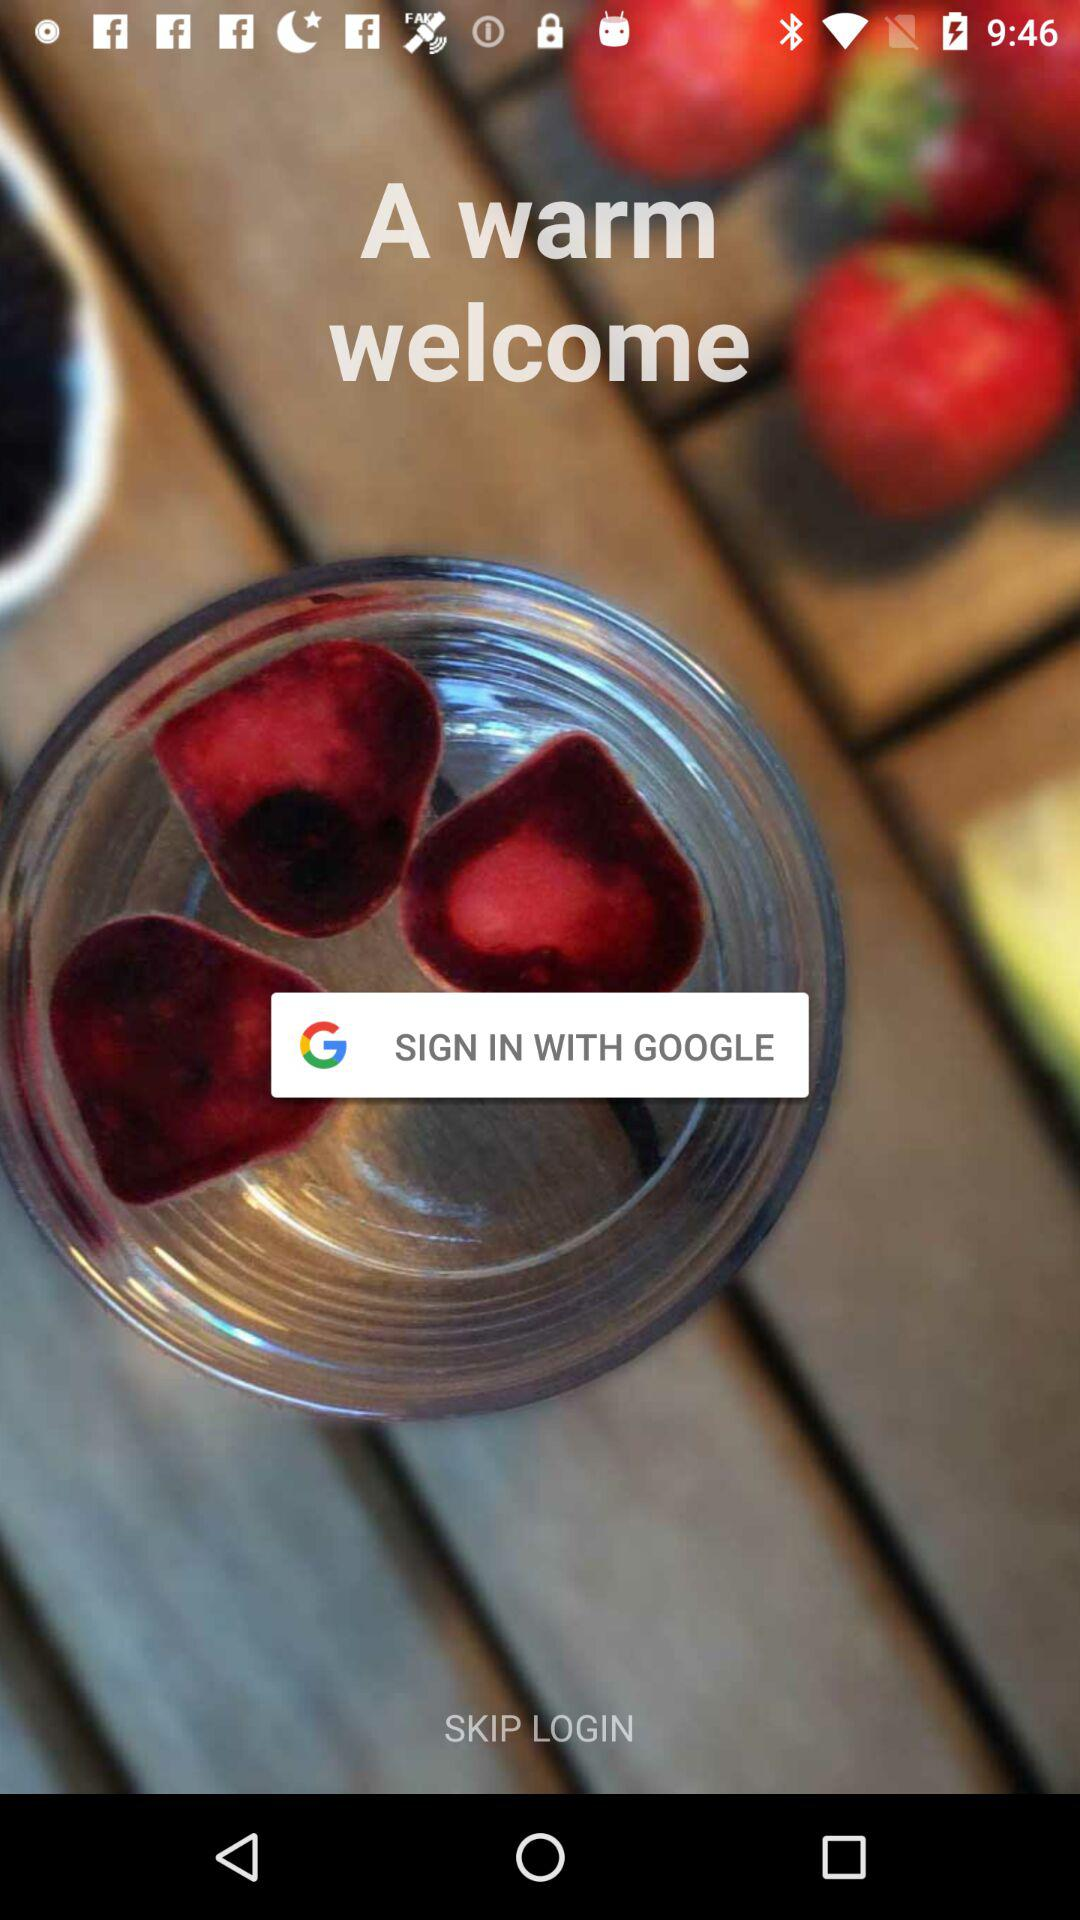What option is given for signing in? The option given for signing in is "GOOGLE". 